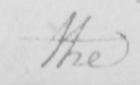Can you read and transcribe this handwriting? the 